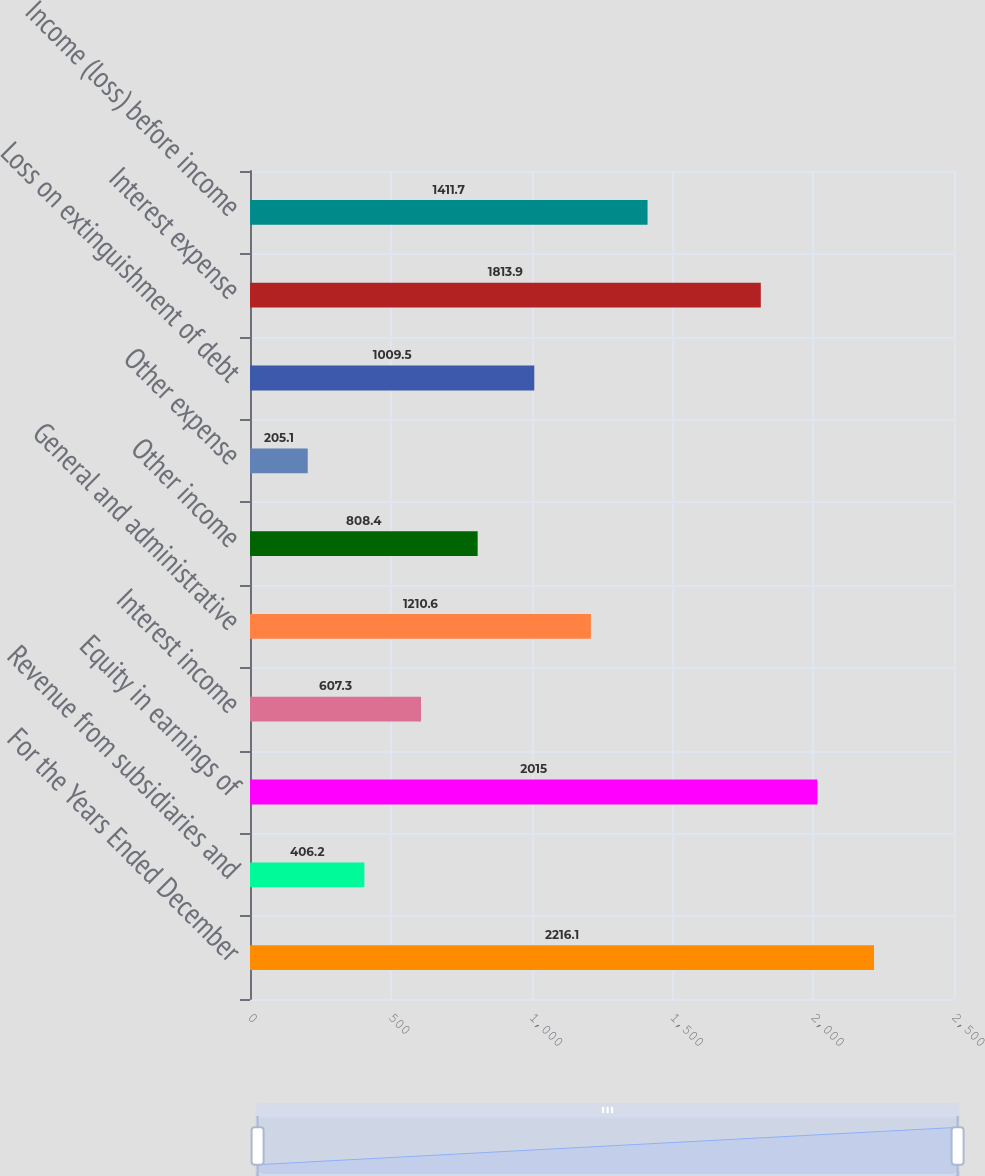Convert chart to OTSL. <chart><loc_0><loc_0><loc_500><loc_500><bar_chart><fcel>For the Years Ended December<fcel>Revenue from subsidiaries and<fcel>Equity in earnings of<fcel>Interest income<fcel>General and administrative<fcel>Other income<fcel>Other expense<fcel>Loss on extinguishment of debt<fcel>Interest expense<fcel>Income (loss) before income<nl><fcel>2216.1<fcel>406.2<fcel>2015<fcel>607.3<fcel>1210.6<fcel>808.4<fcel>205.1<fcel>1009.5<fcel>1813.9<fcel>1411.7<nl></chart> 